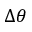Convert formula to latex. <formula><loc_0><loc_0><loc_500><loc_500>\Delta \theta</formula> 